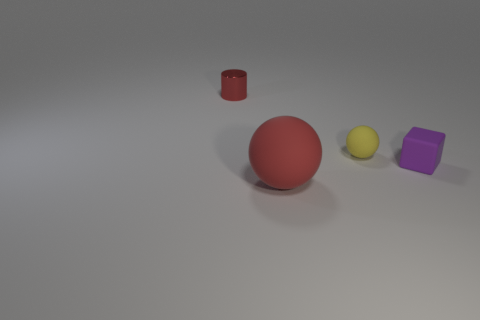What is the size of the red object that is made of the same material as the yellow ball?
Your answer should be compact. Large. What number of objects are either objects that are in front of the tiny matte cube or matte things that are to the right of the small sphere?
Offer a terse response. 2. Is the number of small yellow matte objects behind the small metal cylinder the same as the number of rubber spheres that are behind the tiny yellow matte thing?
Ensure brevity in your answer.  Yes. There is a object in front of the purple block; what is its color?
Give a very brief answer. Red. Do the large ball and the thing that is on the left side of the large red sphere have the same color?
Your answer should be compact. Yes. Is the number of purple cubes less than the number of green metal cylinders?
Your answer should be compact. No. There is a matte sphere that is on the left side of the small yellow sphere; does it have the same color as the tiny cylinder?
Provide a short and direct response. Yes. What number of red cylinders are the same size as the cube?
Make the answer very short. 1. Is there a rubber sphere that has the same color as the shiny cylinder?
Your answer should be very brief. Yes. Is the purple thing made of the same material as the tiny red cylinder?
Your answer should be very brief. No. 